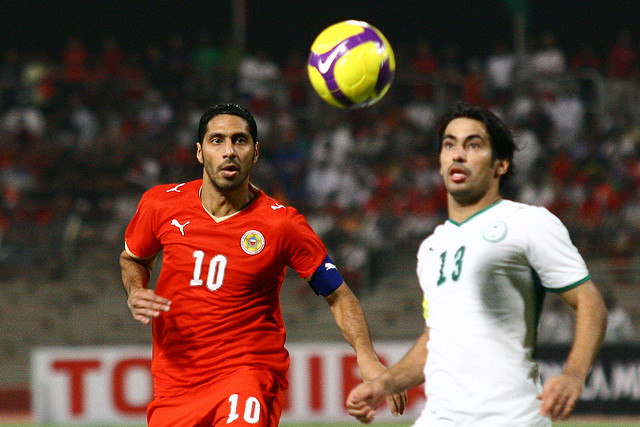Please identify all text content in this image. 10 10 13 